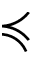<formula> <loc_0><loc_0><loc_500><loc_500>\prec c u r l y e q</formula> 